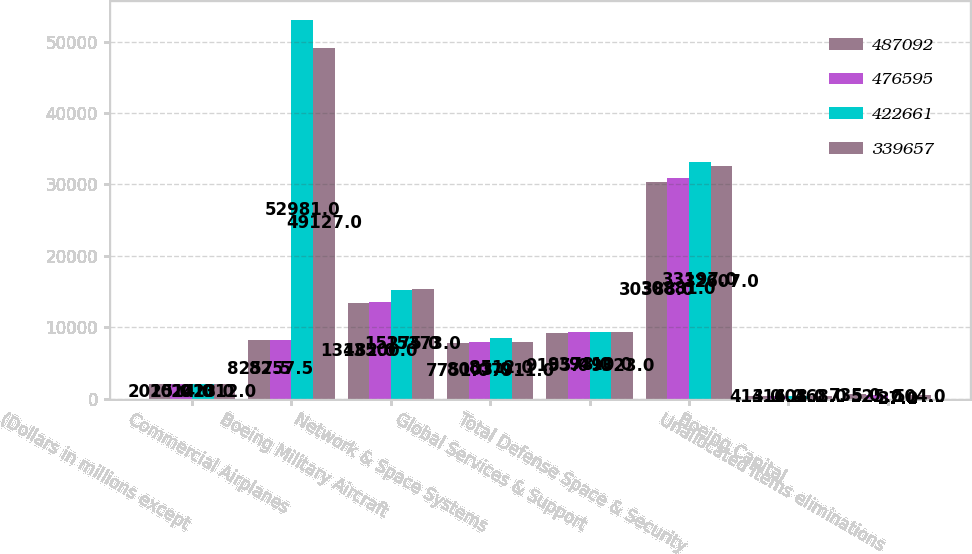<chart> <loc_0><loc_0><loc_500><loc_500><stacked_bar_chart><ecel><fcel>(Dollars in millions except<fcel>Commercial Airplanes<fcel>Boeing Military Aircraft<fcel>Network & Space Systems<fcel>Global Services & Support<fcel>Total Defense Space & Security<fcel>Boeing Capital<fcel>Unallocated items eliminations<nl><fcel>487092<fcel>2015<fcel>8257.5<fcel>13482<fcel>7751<fcel>9155<fcel>30388<fcel>413<fcel>735<nl><fcel>476595<fcel>2014<fcel>8257.5<fcel>13500<fcel>8003<fcel>9378<fcel>30881<fcel>416<fcel>525<nl><fcel>422661<fcel>2013<fcel>52981<fcel>15275<fcel>8512<fcel>9410<fcel>33197<fcel>408<fcel>37<nl><fcel>339657<fcel>2012<fcel>49127<fcel>15373<fcel>7911<fcel>9323<fcel>32607<fcel>468<fcel>504<nl></chart> 